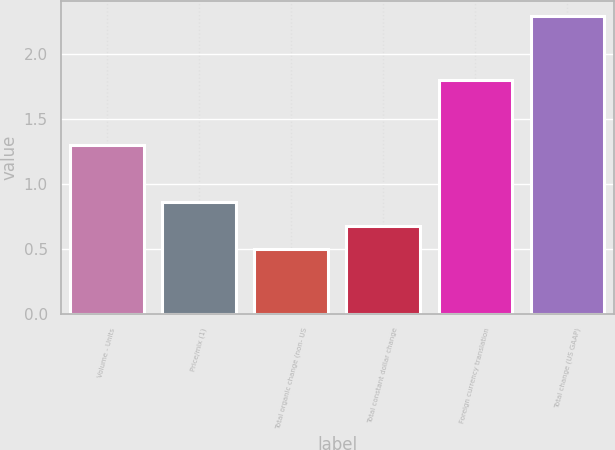<chart> <loc_0><loc_0><loc_500><loc_500><bar_chart><fcel>Volume - Units<fcel>Price/mix (1)<fcel>Total organic change (non- US<fcel>Total constant dollar change<fcel>Foreign currency translation<fcel>Total change (US GAAP)<nl><fcel>1.3<fcel>0.86<fcel>0.5<fcel>0.68<fcel>1.8<fcel>2.3<nl></chart> 